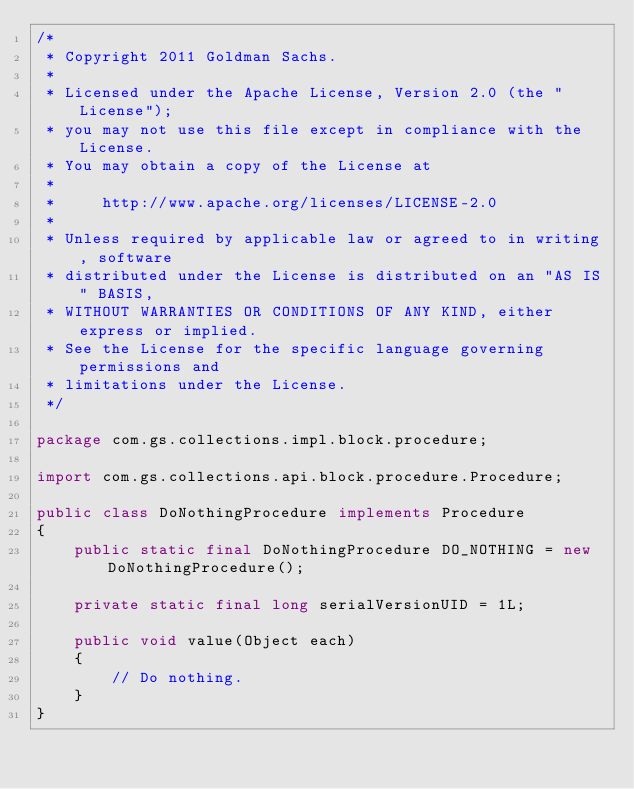Convert code to text. <code><loc_0><loc_0><loc_500><loc_500><_Java_>/*
 * Copyright 2011 Goldman Sachs.
 *
 * Licensed under the Apache License, Version 2.0 (the "License");
 * you may not use this file except in compliance with the License.
 * You may obtain a copy of the License at
 *
 *     http://www.apache.org/licenses/LICENSE-2.0
 *
 * Unless required by applicable law or agreed to in writing, software
 * distributed under the License is distributed on an "AS IS" BASIS,
 * WITHOUT WARRANTIES OR CONDITIONS OF ANY KIND, either express or implied.
 * See the License for the specific language governing permissions and
 * limitations under the License.
 */

package com.gs.collections.impl.block.procedure;

import com.gs.collections.api.block.procedure.Procedure;

public class DoNothingProcedure implements Procedure
{
    public static final DoNothingProcedure DO_NOTHING = new DoNothingProcedure();

    private static final long serialVersionUID = 1L;

    public void value(Object each)
    {
        // Do nothing.
    }
}
</code> 